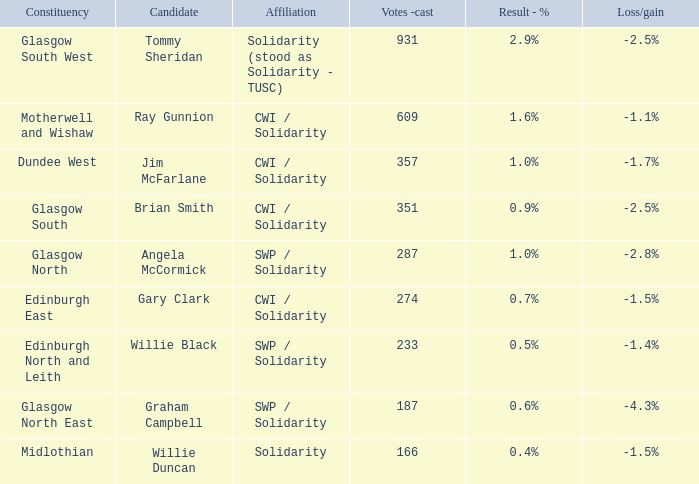What was the loss/gain when the affiliation was solidarity? -1.5%. 